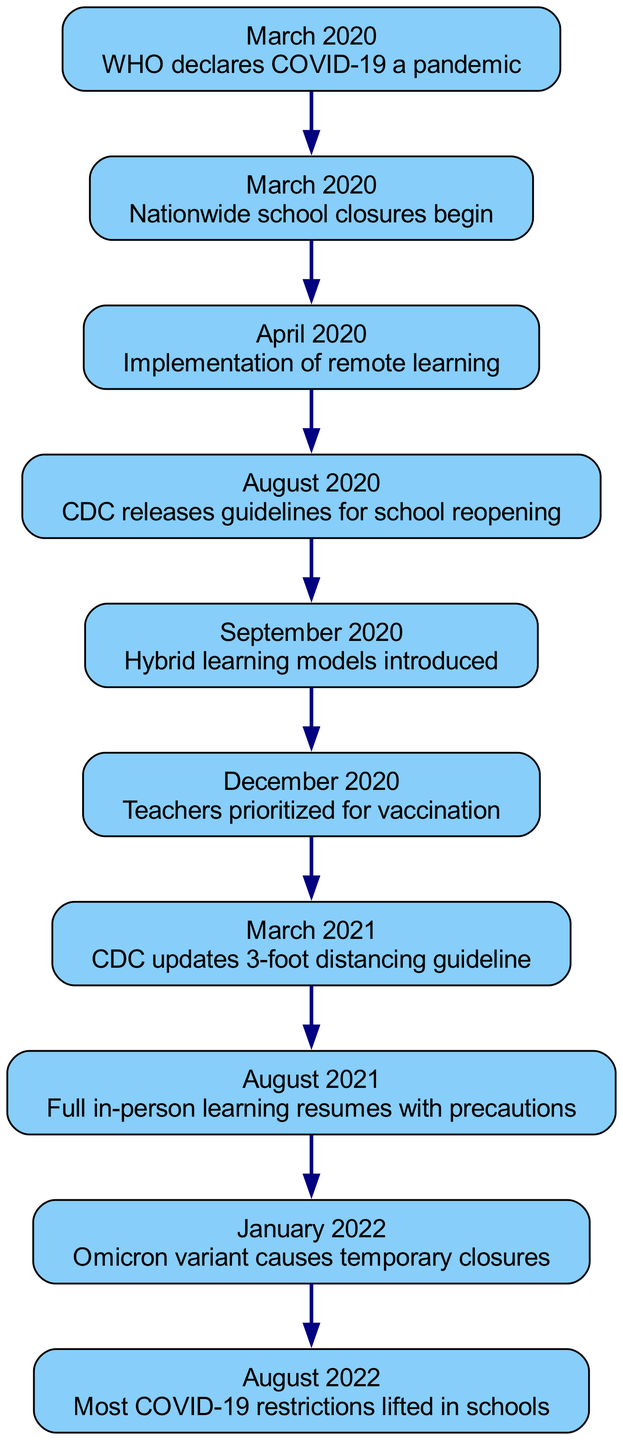What significant event occurred in March 2020? The first node in the diagram states that the WHO declared COVID-19 a pandemic in March 2020. This is the first key event listed.
Answer: WHO declares COVID-19 a pandemic How many events are listed in the timeline? The timeline contains a total of 10 key events, indicated by the number of nodes in the diagram.
Answer: 10 What learning model was introduced in September 2020? In September 2020, the diagram shows that hybrid learning models were introduced, as stated in the corresponding node.
Answer: Hybrid learning models Which month did teachers get prioritized for vaccination? The diagram indicates that in December 2020, teachers were prioritized for vaccination, as mentioned in the respective event node.
Answer: December 2020 What was the outcome of the Omicron variant in January 2022? According to the diagram, the Omicron variant led to temporary closures in January 2022, which is directly stated in the node for that event.
Answer: Temporary closures What change was made to the distancing guideline by the CDC in March 2021? The timeline shows that in March 2021, the CDC updated the 3-foot distancing guideline, as noted in that specific event node.
Answer: 3-foot distancing guideline Which event marks the return to full in-person learning? The diagram indicates that full in-person learning resumed with precautions in August 2021, making this the event that marks that return.
Answer: Full in-person learning resumes with precautions What type of restrictions were lifted in August 2022? The very last event in the timeline specifies that most COVID-19 restrictions were lifted in schools in August 2022.
Answer: Most COVID-19 restrictions lifted in schools What trend is observed from the timeline regarding school operations? Analyzing the diagram, it is evident that there is a progression from school closures to remote learning and eventually back to in-person learning, indicating a returning trend towards normalcy over time.
Answer: Returning trend towards normalcy 